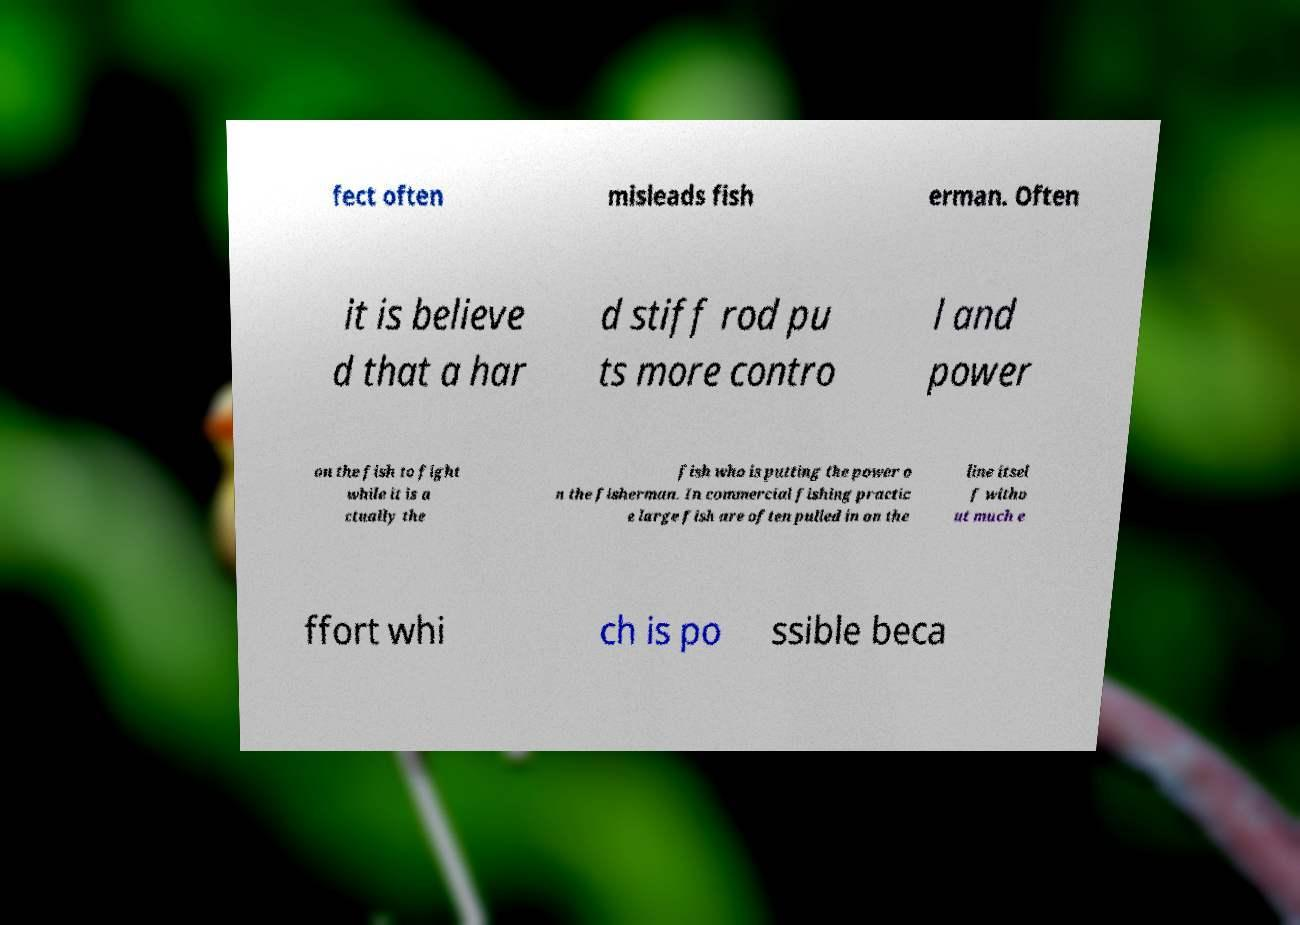Could you extract and type out the text from this image? fect often misleads fish erman. Often it is believe d that a har d stiff rod pu ts more contro l and power on the fish to fight while it is a ctually the fish who is putting the power o n the fisherman. In commercial fishing practic e large fish are often pulled in on the line itsel f witho ut much e ffort whi ch is po ssible beca 